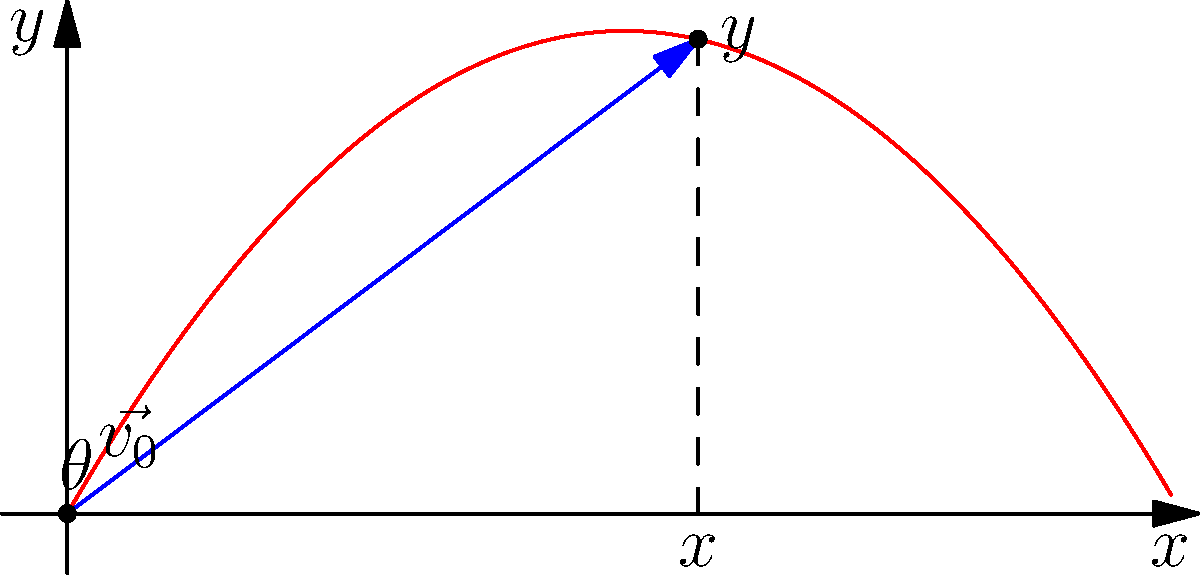In your latest suspense thriller, a crucial piece of evidence is falling from a tall building. To create the perfect shot, you need to calculate its position after 2 seconds. The object is thrown with an initial velocity of 20 m/s at an angle of 60° above the horizontal. Neglecting air resistance, what are the x and y components of the object's position vector after 2 seconds? Give your answer in the form (x, y) in meters, rounded to two decimal places. To solve this problem, we'll use the equations of motion for projectile motion:

1) For the x-component: $x = v_0 \cos(\theta) t$
2) For the y-component: $y = v_0 \sin(\theta) t - \frac{1}{2}gt^2$

Where:
$v_0 = 20$ m/s (initial velocity)
$\theta = 60°$ (angle above horizontal)
$t = 2$ s (time)
$g = 9.8$ m/s² (acceleration due to gravity)

Step 1: Calculate the x-component
$x = v_0 \cos(\theta) t$
$x = 20 \cos(60°) \cdot 2$
$x = 20 \cdot 0.5 \cdot 2 = 20$ m

Step 2: Calculate the y-component
$y = v_0 \sin(\theta) t - \frac{1}{2}gt^2$
$y = 20 \sin(60°) \cdot 2 - \frac{1}{2} \cdot 9.8 \cdot 2^2$
$y = 20 \cdot \frac{\sqrt{3}}{2} \cdot 2 - 4.9 \cdot 4$
$y = 20\sqrt{3} - 19.6 \approx 14.91$ m

Step 3: Combine the results and round to two decimal places
x ≈ 20.00 m
y ≈ 14.91 m
Answer: (20.00, 14.91) 